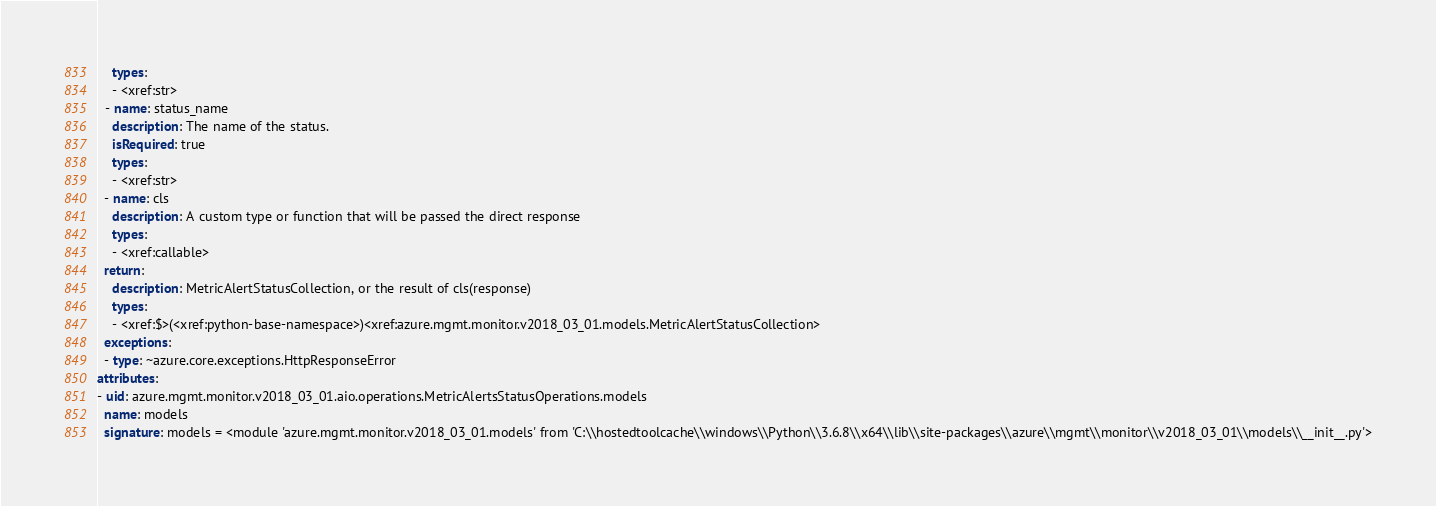<code> <loc_0><loc_0><loc_500><loc_500><_YAML_>    types:
    - <xref:str>
  - name: status_name
    description: The name of the status.
    isRequired: true
    types:
    - <xref:str>
  - name: cls
    description: A custom type or function that will be passed the direct response
    types:
    - <xref:callable>
  return:
    description: MetricAlertStatusCollection, or the result of cls(response)
    types:
    - <xref:$>(<xref:python-base-namespace>)<xref:azure.mgmt.monitor.v2018_03_01.models.MetricAlertStatusCollection>
  exceptions:
  - type: ~azure.core.exceptions.HttpResponseError
attributes:
- uid: azure.mgmt.monitor.v2018_03_01.aio.operations.MetricAlertsStatusOperations.models
  name: models
  signature: models = <module 'azure.mgmt.monitor.v2018_03_01.models' from 'C:\\hostedtoolcache\\windows\\Python\\3.6.8\\x64\\lib\\site-packages\\azure\\mgmt\\monitor\\v2018_03_01\\models\\__init__.py'>
</code> 